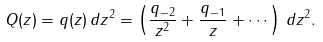Convert formula to latex. <formula><loc_0><loc_0><loc_500><loc_500>Q ( z ) = q ( z ) \, d z ^ { 2 } = \left ( \frac { q _ { - 2 } } { z ^ { 2 } } + \frac { q _ { - 1 } } { z } + \cdots \right ) \, d z ^ { 2 } .</formula> 